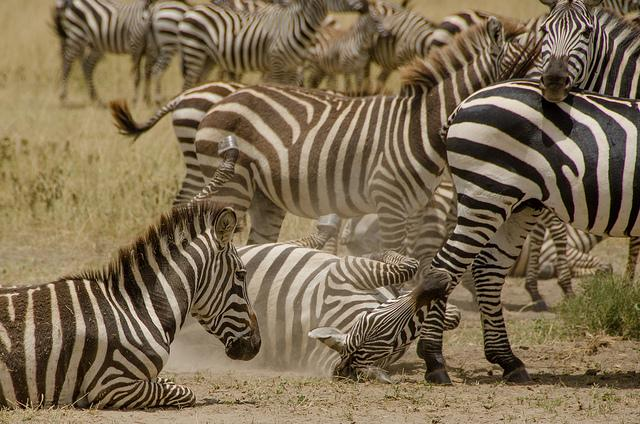How would these animals be classified? zebras 